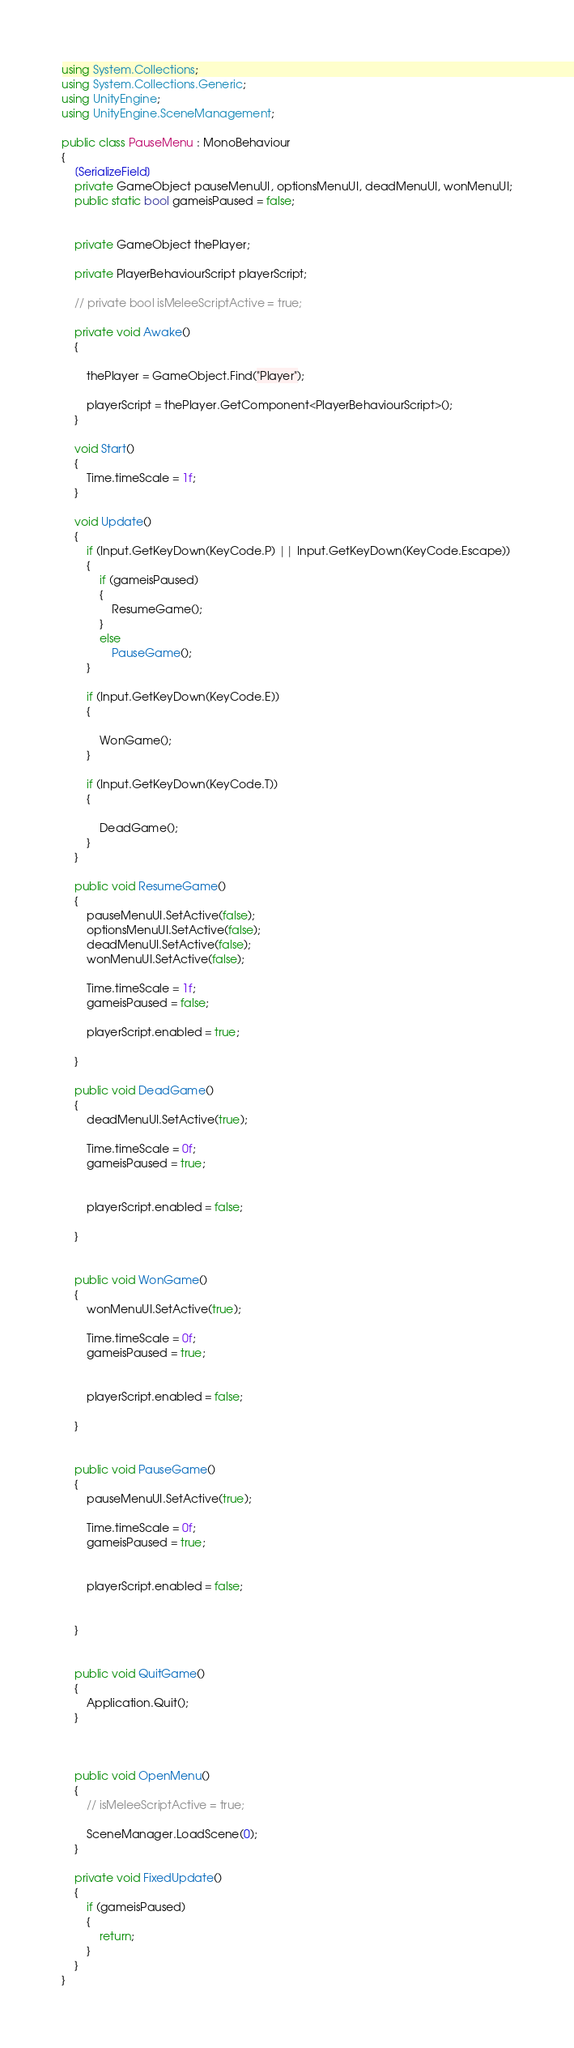<code> <loc_0><loc_0><loc_500><loc_500><_C#_>using System.Collections;
using System.Collections.Generic;
using UnityEngine;
using UnityEngine.SceneManagement;

public class PauseMenu : MonoBehaviour
{
    [SerializeField]
    private GameObject pauseMenuUI, optionsMenuUI, deadMenuUI, wonMenuUI;
    public static bool gameisPaused = false;


    private GameObject thePlayer;

    private PlayerBehaviourScript playerScript;

    // private bool isMeleeScriptActive = true;

    private void Awake()
    {

        thePlayer = GameObject.Find("Player");

        playerScript = thePlayer.GetComponent<PlayerBehaviourScript>();
    }

    void Start()
    {
        Time.timeScale = 1f;
    }

    void Update()
    {
        if (Input.GetKeyDown(KeyCode.P) || Input.GetKeyDown(KeyCode.Escape))
        {
            if (gameisPaused)
            {
                ResumeGame();
            }
            else
                PauseGame();
        }

        if (Input.GetKeyDown(KeyCode.E))
        {

            WonGame();
        }

        if (Input.GetKeyDown(KeyCode.T))
        {

            DeadGame();
        }
    }

    public void ResumeGame()
    {
        pauseMenuUI.SetActive(false);
        optionsMenuUI.SetActive(false);
        deadMenuUI.SetActive(false);
        wonMenuUI.SetActive(false);

        Time.timeScale = 1f;
        gameisPaused = false;

        playerScript.enabled = true;

    }

    public void DeadGame()
    {
        deadMenuUI.SetActive(true);

        Time.timeScale = 0f;
        gameisPaused = true;


        playerScript.enabled = false;

    }


    public void WonGame()
    {
        wonMenuUI.SetActive(true);

        Time.timeScale = 0f;
        gameisPaused = true;


        playerScript.enabled = false;

    }


    public void PauseGame()
    {
        pauseMenuUI.SetActive(true);

        Time.timeScale = 0f;
        gameisPaused = true;


        playerScript.enabled = false;

       
    }


    public void QuitGame()
    {
        Application.Quit();
    }



    public void OpenMenu()
    {
        // isMeleeScriptActive = true;

        SceneManager.LoadScene(0);
    }

    private void FixedUpdate()
    {
        if (gameisPaused)
        {
            return;
        }
    }
}
</code> 